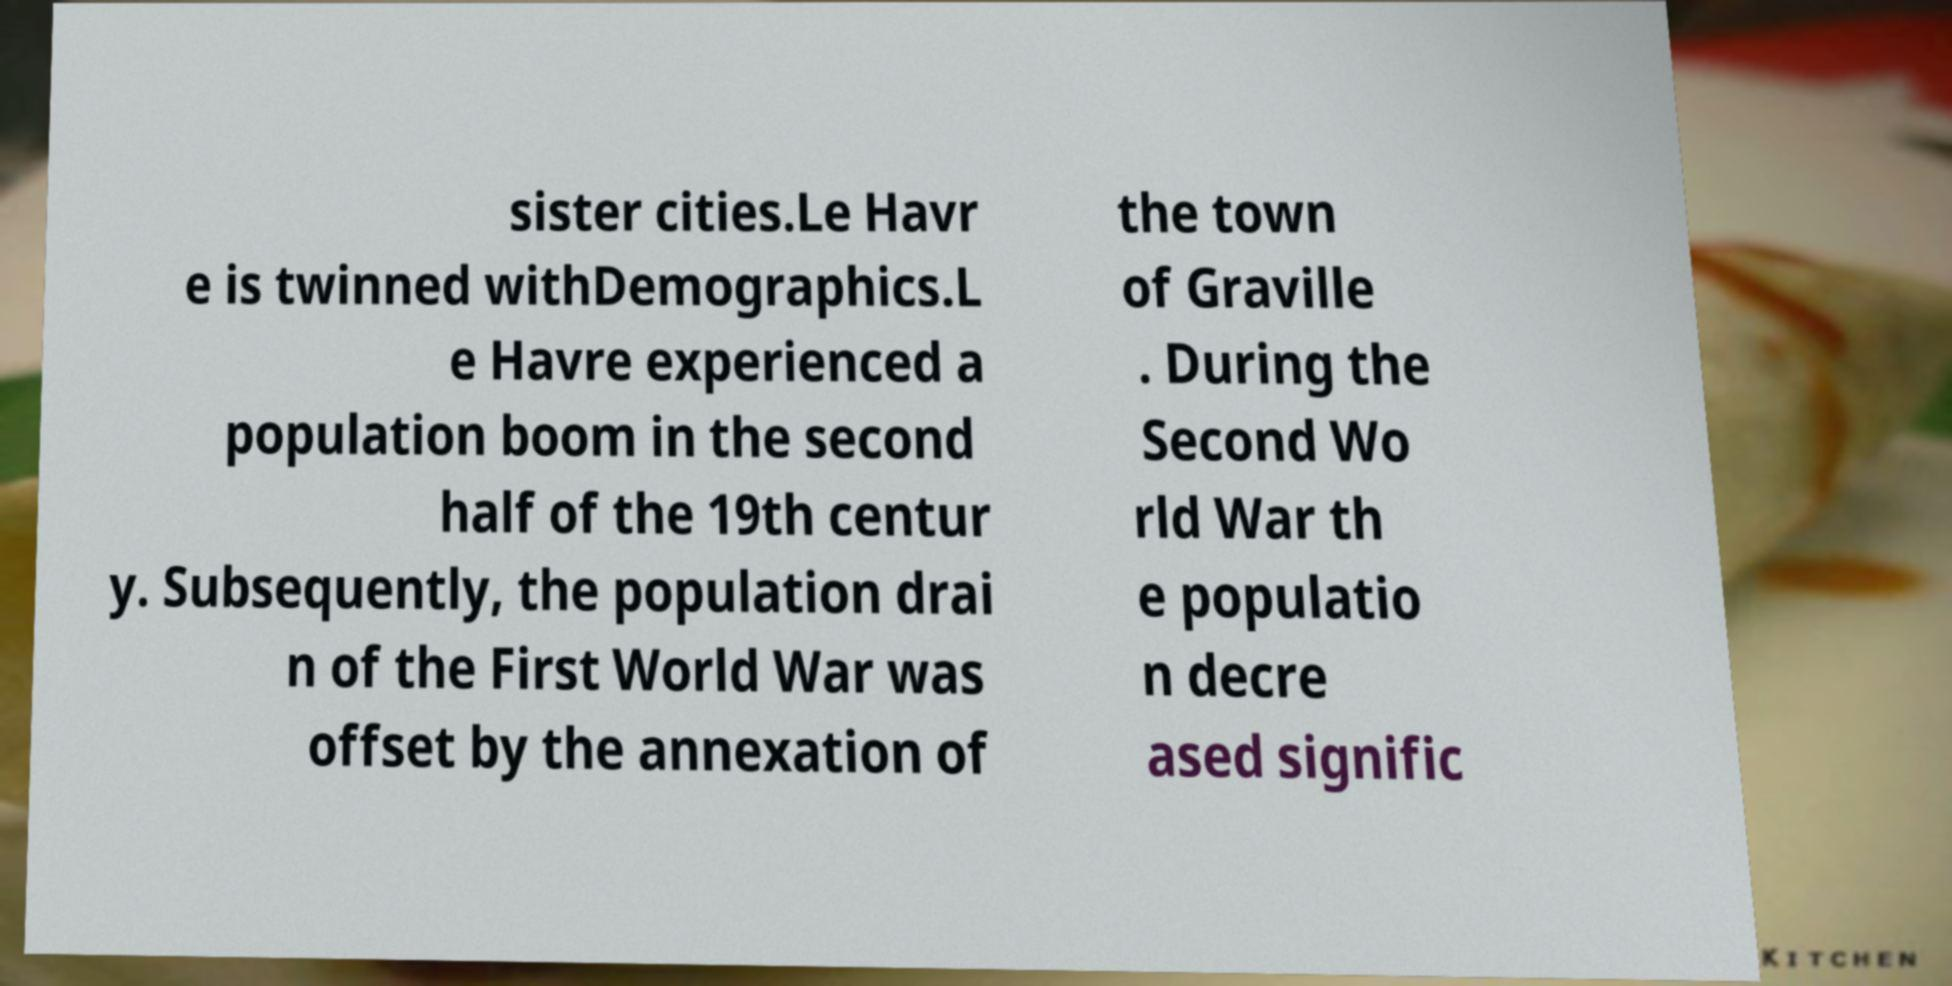Can you accurately transcribe the text from the provided image for me? sister cities.Le Havr e is twinned withDemographics.L e Havre experienced a population boom in the second half of the 19th centur y. Subsequently, the population drai n of the First World War was offset by the annexation of the town of Graville . During the Second Wo rld War th e populatio n decre ased signific 